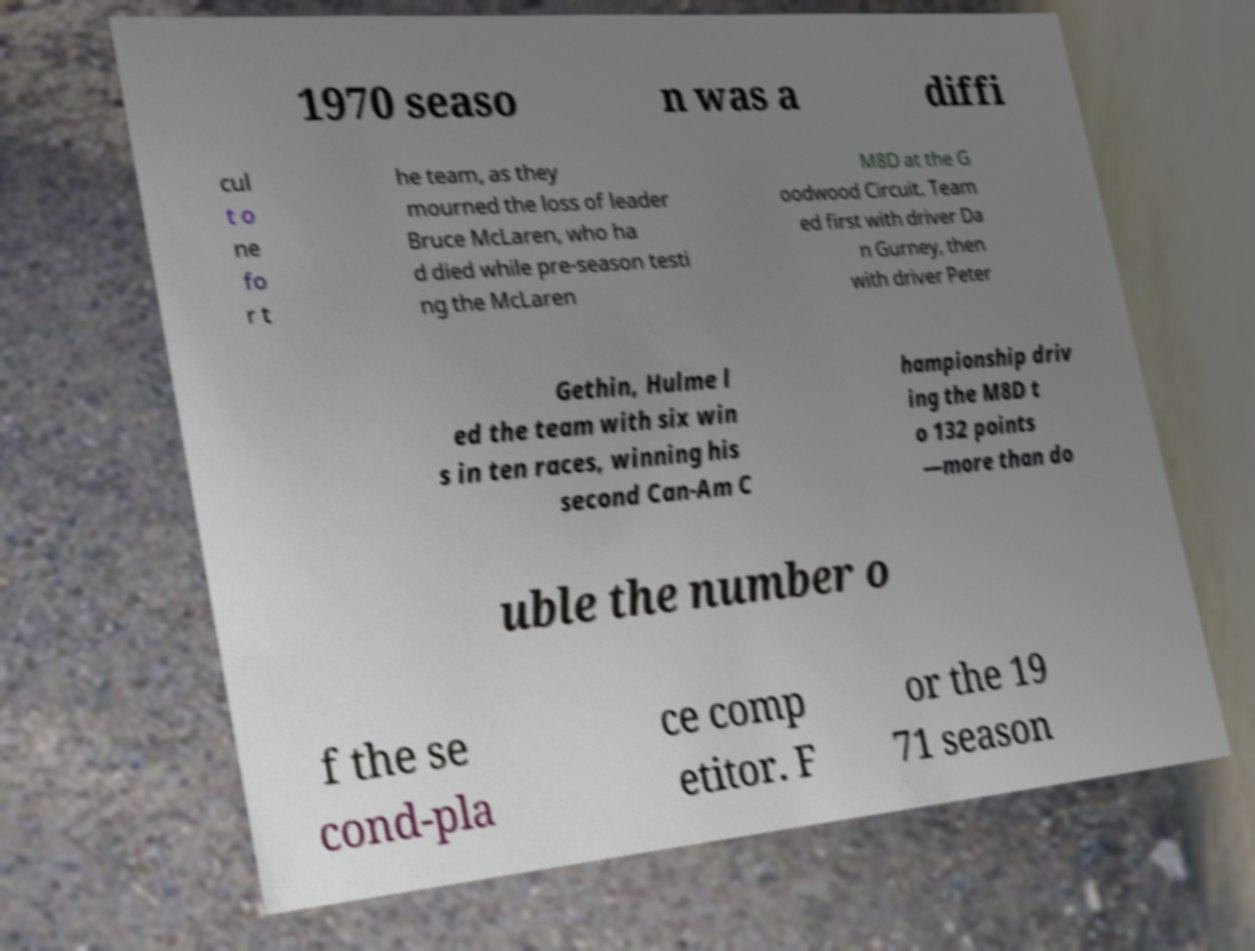What messages or text are displayed in this image? I need them in a readable, typed format. 1970 seaso n was a diffi cul t o ne fo r t he team, as they mourned the loss of leader Bruce McLaren, who ha d died while pre-season testi ng the McLaren M8D at the G oodwood Circuit. Team ed first with driver Da n Gurney, then with driver Peter Gethin, Hulme l ed the team with six win s in ten races, winning his second Can-Am C hampionship driv ing the M8D t o 132 points —more than do uble the number o f the se cond-pla ce comp etitor. F or the 19 71 season 